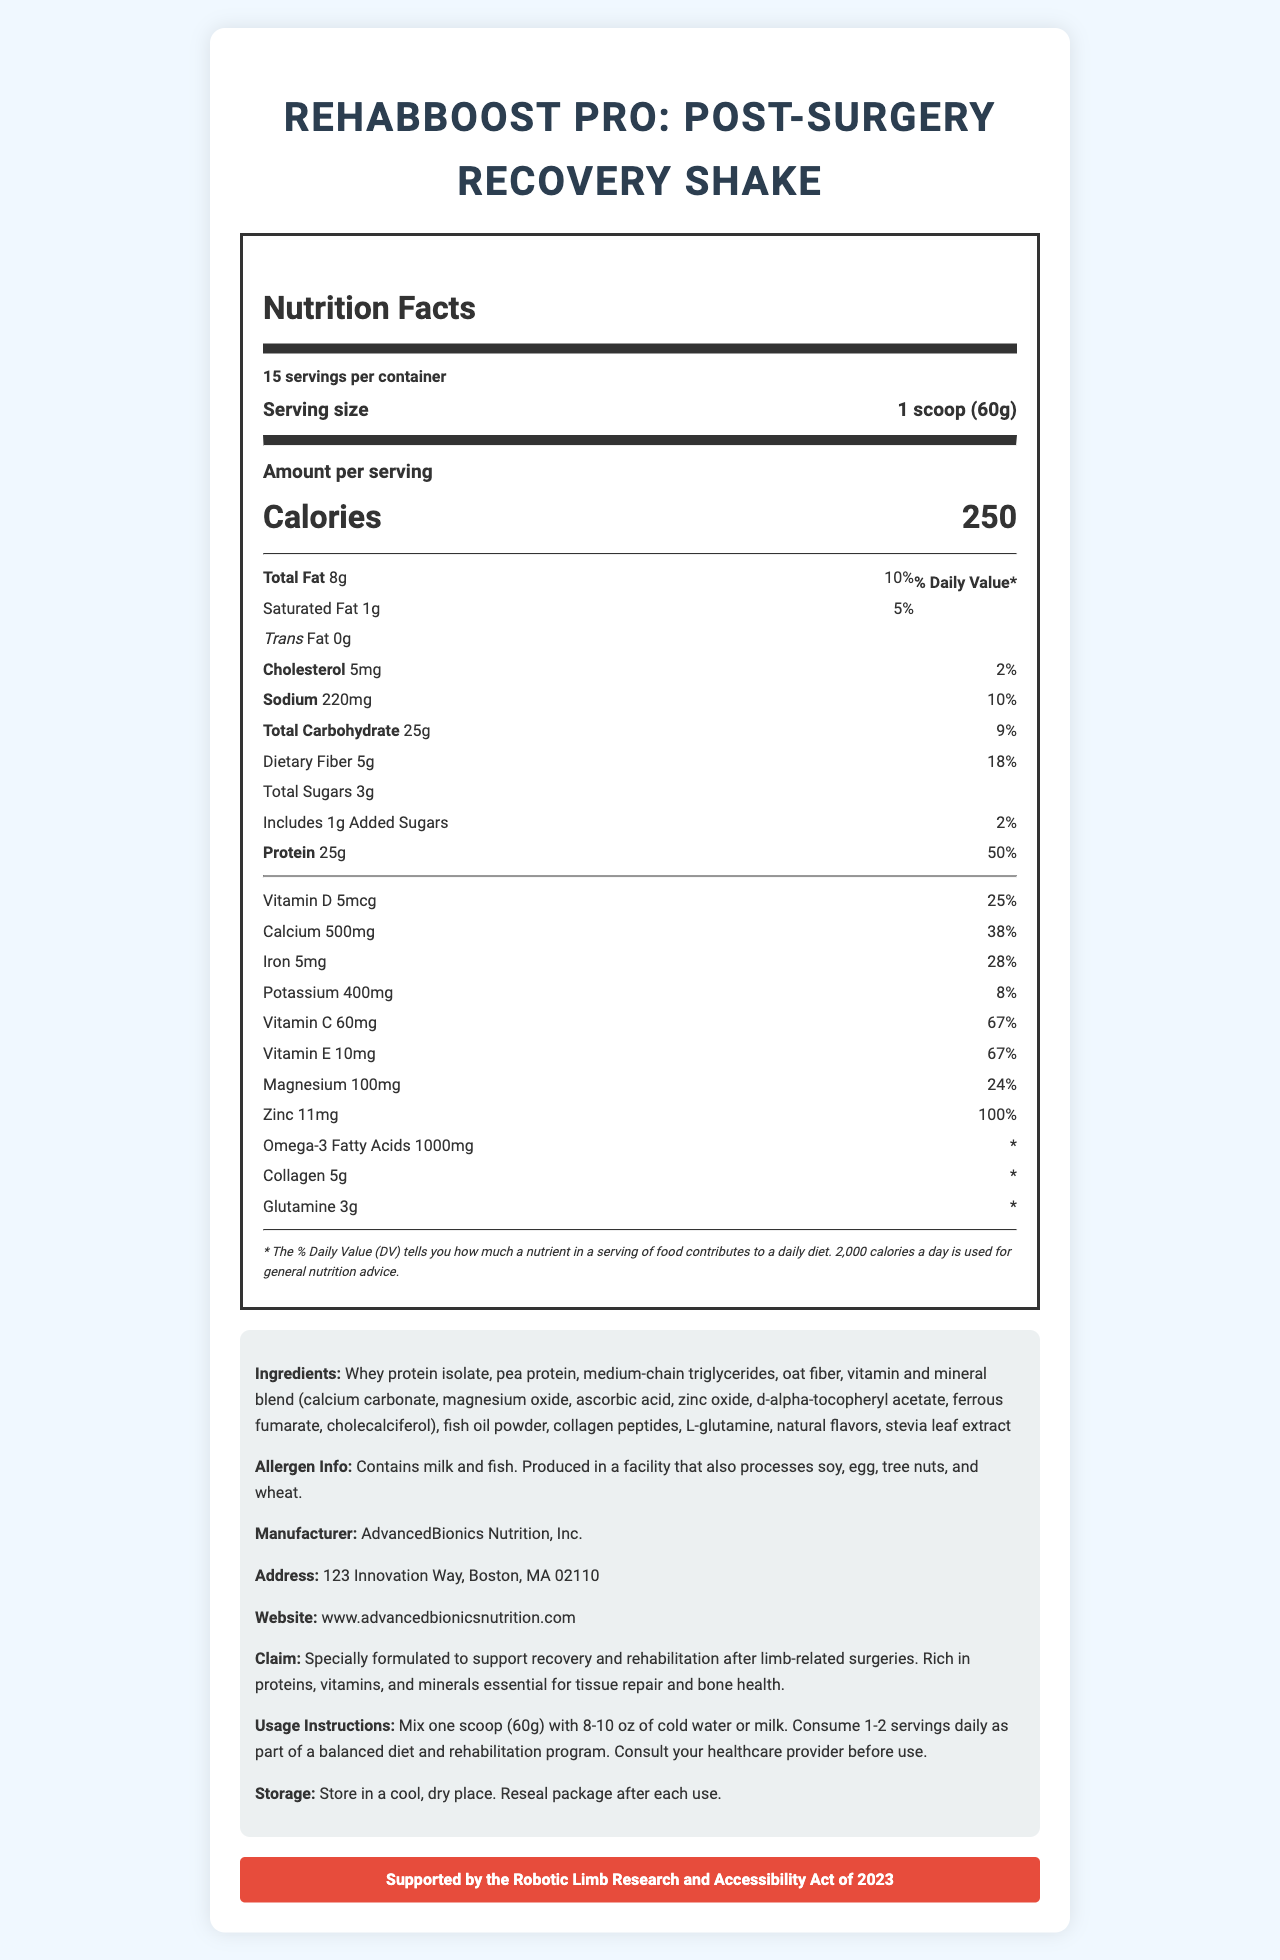what is the serving size? The serving size is explicitly mentioned in the document as "1 scoop (60g)".
Answer: 1 scoop (60g) how many servings are there per container? The document states that there are 15 servings per container.
Answer: 15 what is the amount of protein per serving? The protein content per serving is listed as 25g.
Answer: 25g what is the daily value percentage for dietary fiber? The daily value percentage for dietary fiber is given as 18%.
Answer: 18% what allergens does the product contain? The document lists the allergens as contained in the product: "Contains milk and fish."
Answer: Milk and fish Which nutrient has the highest daily value percentage? A. Vitamin D B. Iron C. Zinc D. Calcium Zinc has the highest daily value percentage at 100%, compared to other listed nutrients.
Answer: C. Zinc What is the calorie content per serving? A. 200 calories B. 250 calories C. 300 calories D. 350 calories The document specifies that each serving contains 250 calories.
Answer: B. 250 calories Is there glutamine in the product? Yes/No The ingredient list includes glutamine with an amount of 3g per serving.
Answer: Yes Summarize the main benefit of this product for post-surgery recovery. The document's claim section highlights the main benefit explicitly, stating that the shake is "specially formulated to support recovery and rehabilitation after limb-related surgeries."
Answer: The shake is formulated to support recovery and rehabilitation after limb-related surgeries by being rich in proteins, vitamins, and minerals essential for tissue repair and bone health. how much medium-chain triglycerides is present? The document does not provide specific information about the amount of medium-chain triglycerides present in the product.
Answer: Cannot be determined 